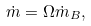Convert formula to latex. <formula><loc_0><loc_0><loc_500><loc_500>\dot { m } = \Omega \dot { m } _ { B } ,</formula> 